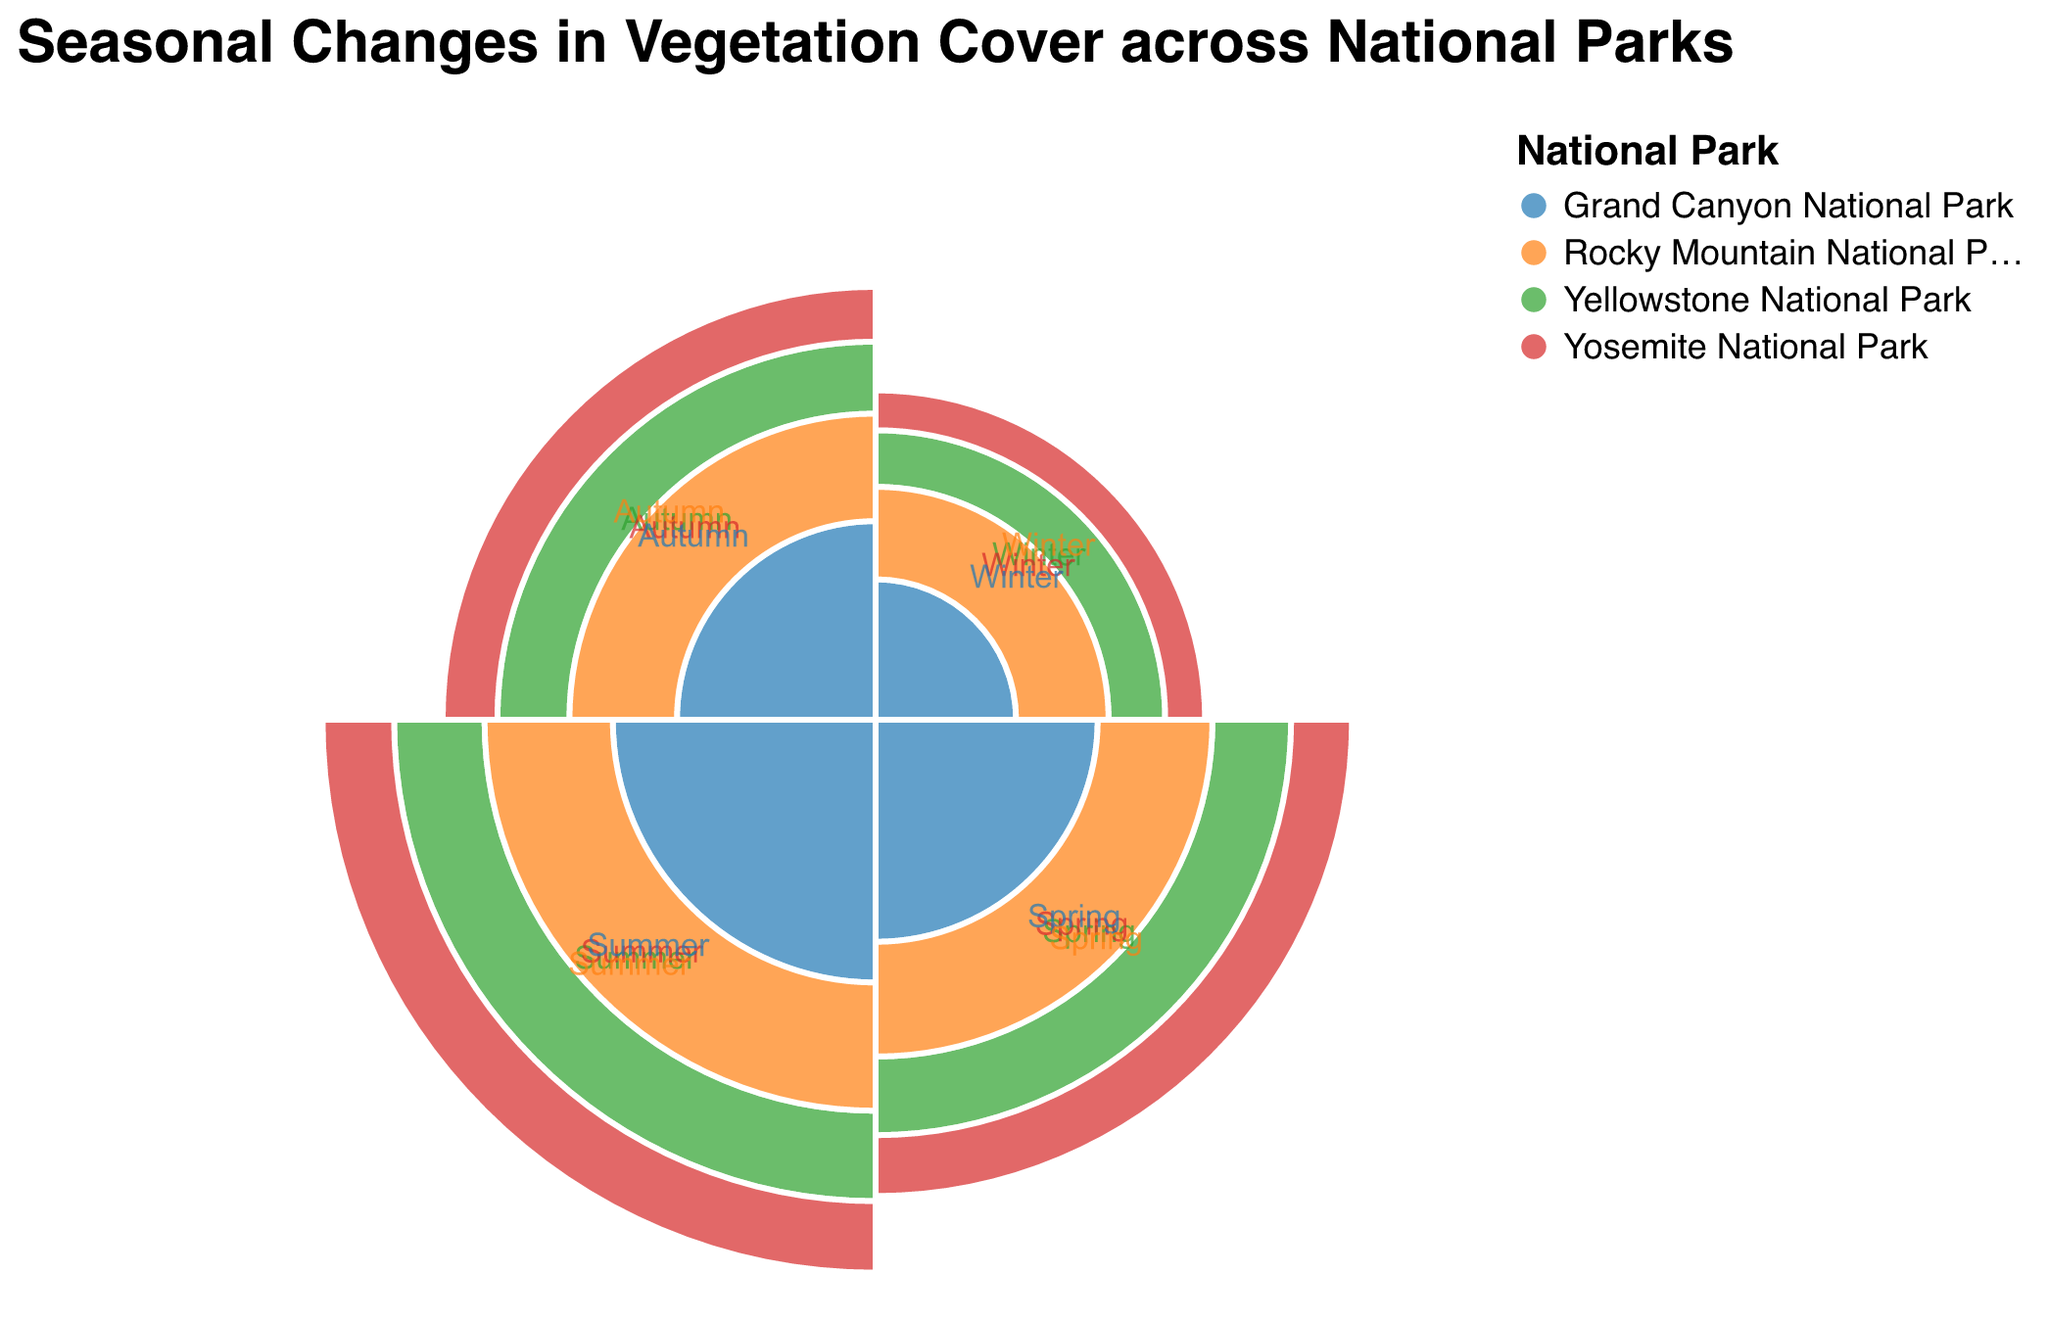What is the title of the chart? The title is clearly displayed at the top of the chart, summarizing the data being presented.
Answer: Seasonal Changes in Vegetation Cover across National Parks Which season has the highest vegetation cover percentage in Rocky Mountain National Park? By examining the arcs representing Rocky Mountain National Park, we see that the summer arc extends furthest from the center, indicating the highest vegetation cover percentage.
Answer: Summer How many national parks are displayed in the chart? The legend associated with the chart lists the names of the national parks represented.
Answer: Four What is the vegetation cover percentage for Yosemite National Park in Spring? By locating the arc corresponding to Yosemite National Park during Spring, the outer edge indicates the percentage.
Answer: 55% Which national park has the lowest vegetation cover percentage in Winter? By comparing the arcs for each national park during Winter, the Grand Canyon National Park arc is the shortest, indicating the lowest percentage.
Answer: Grand Canyon National Park What is the difference in vegetation cover percentage between Winter and Summer in Yellowstone National Park? Subtract the vegetation cover percentage for Winter from that of Summer for Yellowstone National Park: 80% - 30% = 50%.
Answer: 50% What is the average vegetation cover percentage in Spring across all the national parks? Add the percentages for Spring from each national park and divide by the number of parks: (60+55+50+65)/4 = 57.5%.
Answer: 57.5% Which national park experiences the largest change in vegetation cover percentage from Winter to Summer? Subtract the Winter percentage from the Summer percentage for each park and compare the results. Yellowstone National Park has a change of 80-30=50, Yosemite National Park has 75-25=50, Grand Canyon National Park has 70-20=50, Rocky Mountain National Park has 85-35=50, so the largest change is equal across all parks.
Answer: All parks have an equal change How does the vegetation cover percentage in Autumn compare between Yellowstone and Grand Canyon National Parks? Compare the lengths of the arcs representing Autumn for both parks: Yellowstone is 50%, and Grand Canyon is 40%.
Answer: Yellowstone is higher by 10% In which season do all the national parks show their lowest vegetation cover percentage? By observing and comparing the shortest arcs for each park, it's apparent that Winter has the lowest vegetation percentage for all.
Answer: Winter 